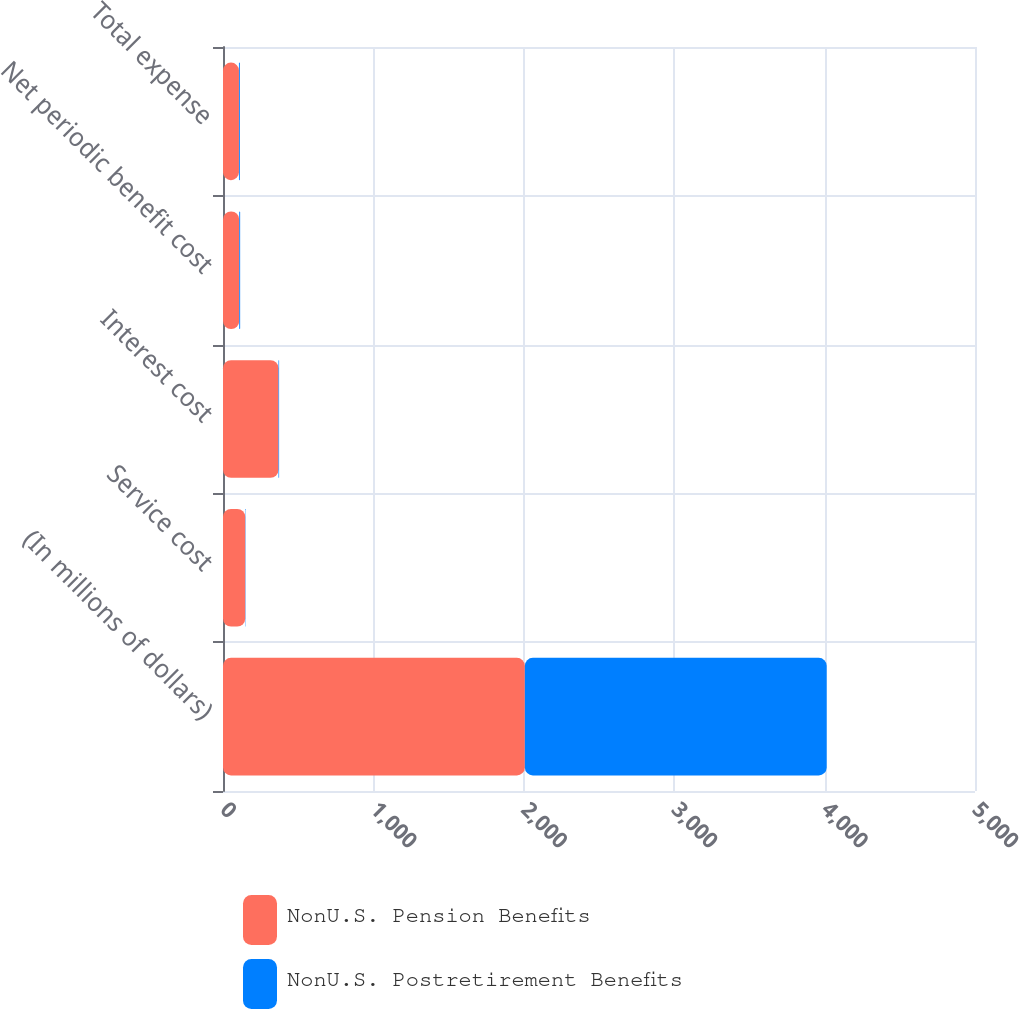Convert chart to OTSL. <chart><loc_0><loc_0><loc_500><loc_500><stacked_bar_chart><ecel><fcel>(In millions of dollars)<fcel>Service cost<fcel>Interest cost<fcel>Net periodic benefit cost<fcel>Total expense<nl><fcel>NonU.S. Pension Benefits<fcel>2007<fcel>148<fcel>369<fcel>108<fcel>106<nl><fcel>NonU.S. Postretirement Benefits<fcel>2007<fcel>2<fcel>4<fcel>6<fcel>6<nl></chart> 